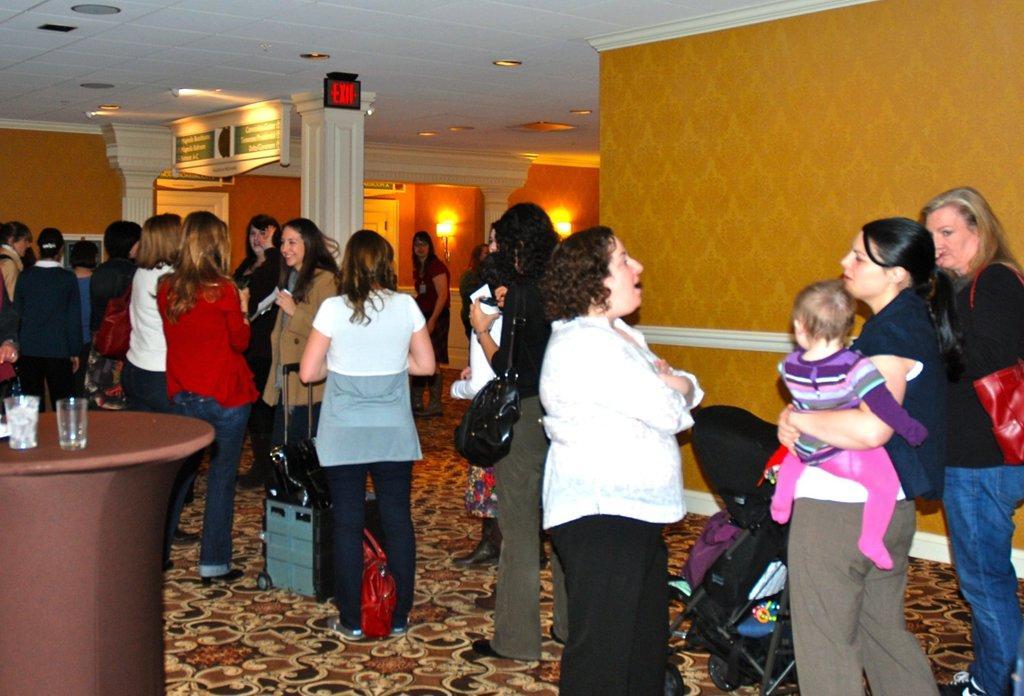Can you describe this image briefly? In this image there are group of women standing on the floor. At the top there is ceiling with the lights. On the left side there is a table on which there are two glasses. On the floor there are bags. In the middle there is a pillar. Beside the pillar there is a board attached to the ceiling. On the right side there is a cradle on the road. 